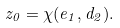<formula> <loc_0><loc_0><loc_500><loc_500>z _ { 0 } = \chi ( e _ { 1 } , d _ { 2 } ) .</formula> 